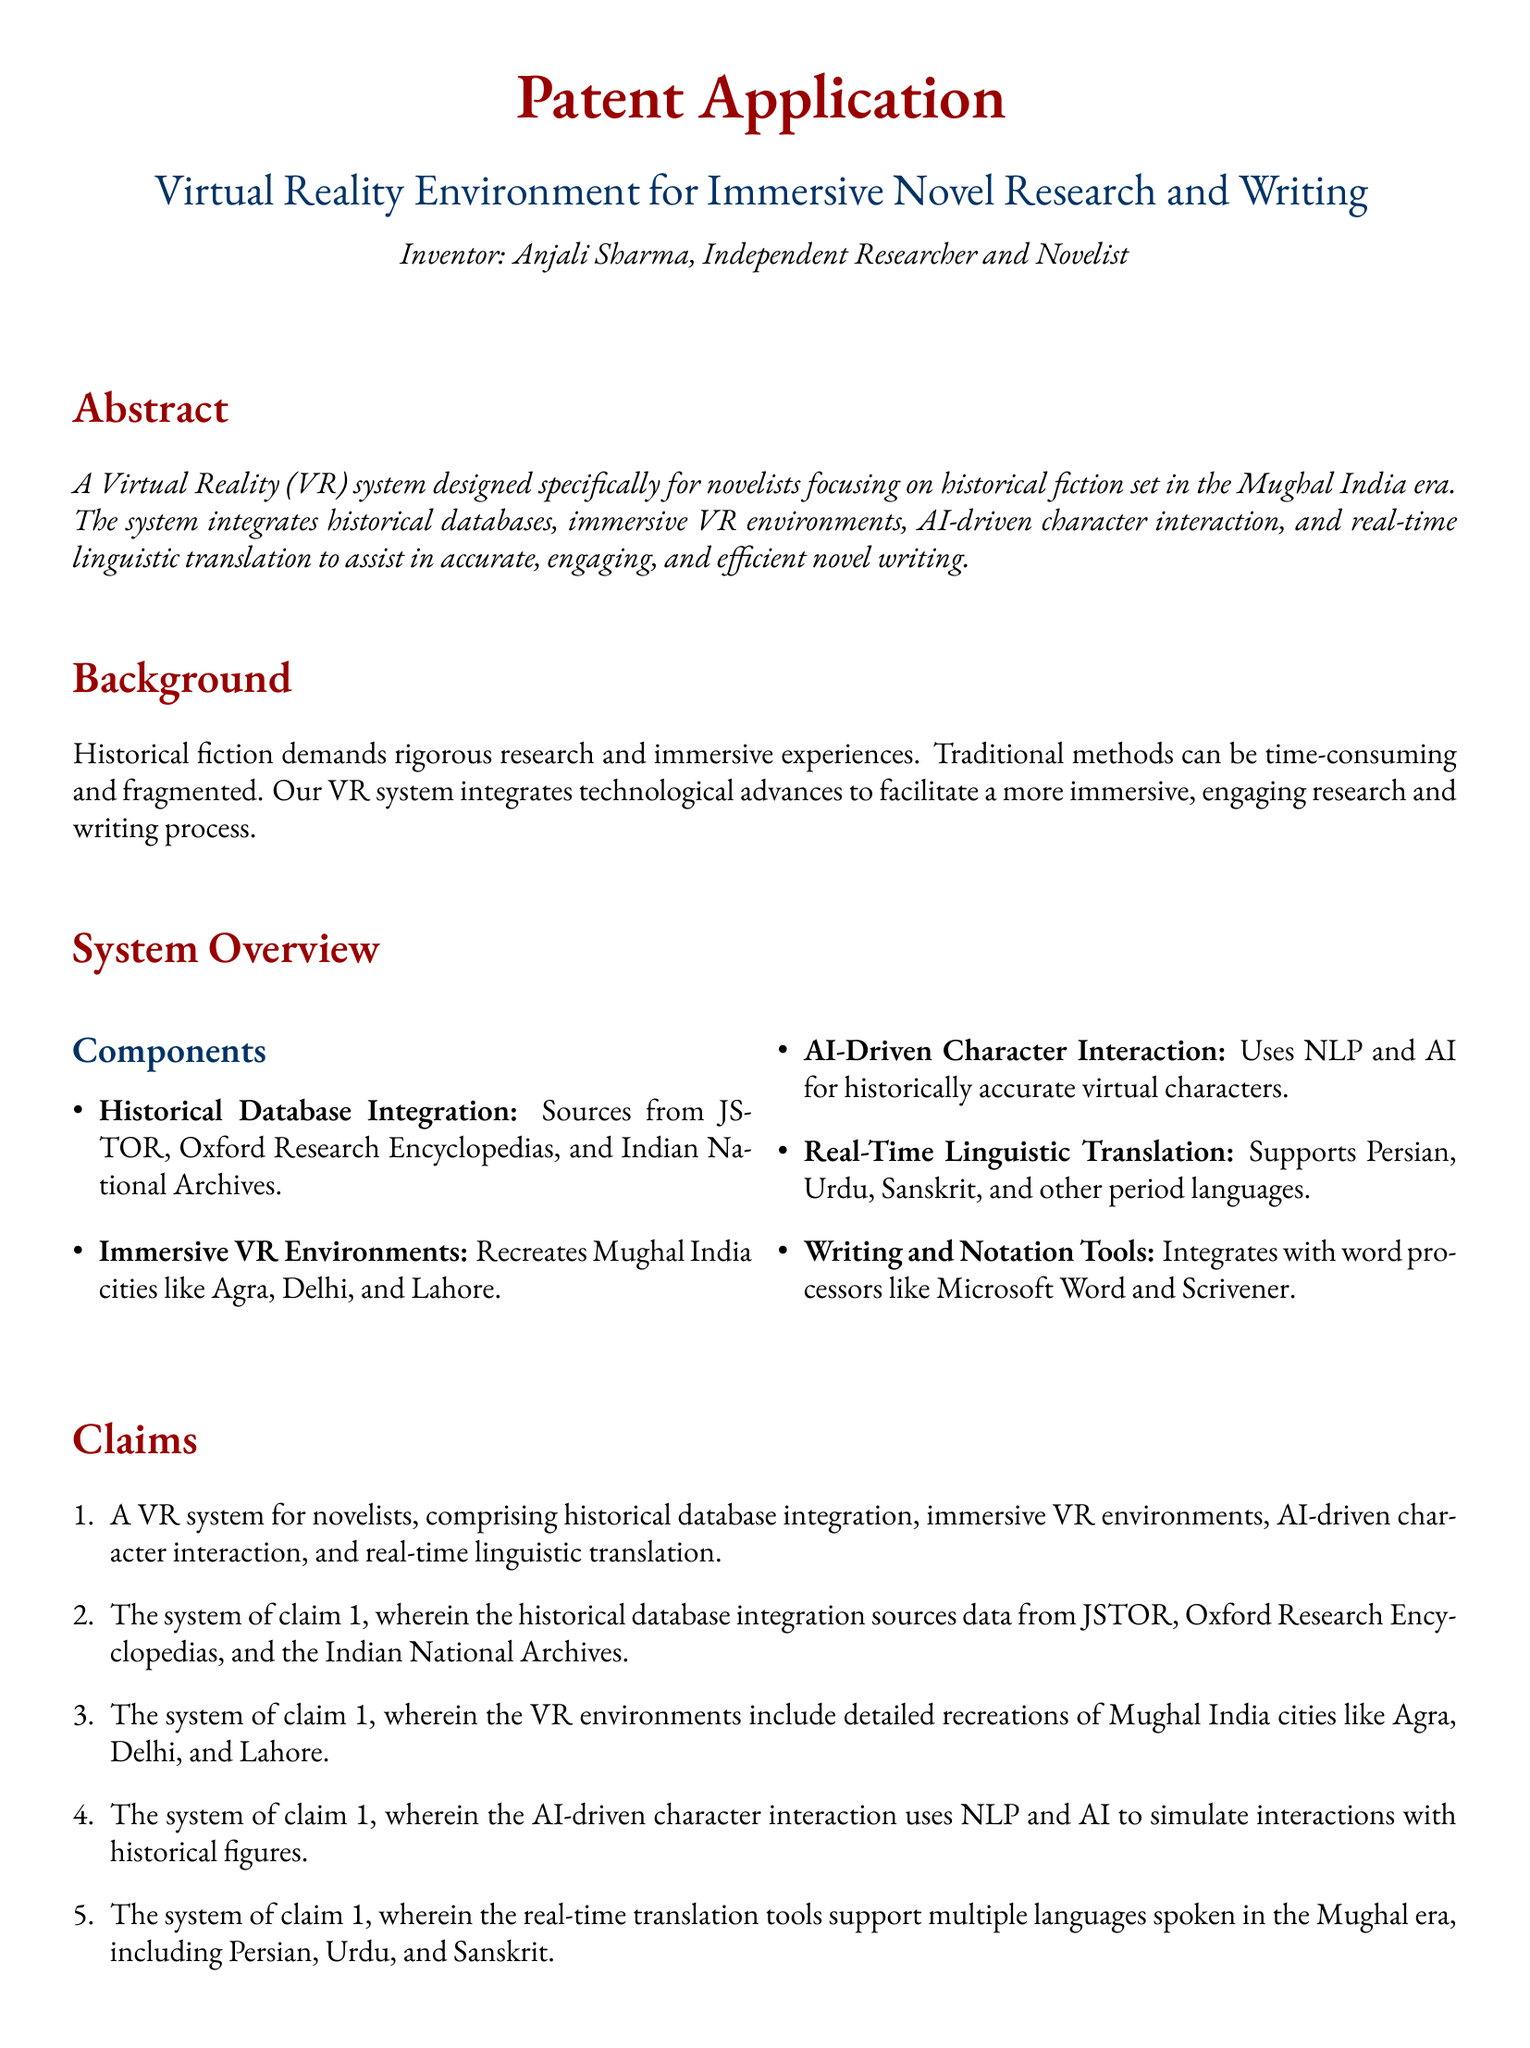What is the name of the inventor? The document states that the inventor is Anjali Sharma.
Answer: Anjali Sharma What is the main purpose of the VR system? The abstract describes the VR system's purpose as assisting novelists in writing historical fiction, focusing on the Mughal India era.
Answer: Immersive novel research and writing Which historical databases are integrated into the system? The claims specify that the system sources data from JSTOR, Oxford Research Encyclopedias, and the Indian National Archives.
Answer: JSTOR, Oxford Research Encyclopedias, Indian National Archives Which cities are recreated in the immersive VR environments? The document mentions that the VR environments include recreations of Agra, Delhi, and Lahore.
Answer: Agra, Delhi, Lahore What type of interaction does the AI-driven component simulate? The system is designed to simulate interactions with historical figures using NLP and AI.
Answer: Interactions with historical figures How many claims are listed in the document? The list of claims includes five distinct entries regarding the system's features.
Answer: Five What languages are supported by the real-time translation tools? The document states that the translation tools support Persian, Urdu, and Sanskrit.
Answer: Persian, Urdu, Sanskrit What kind of writing tools does the system integrate with? The system integrates with popular word processors like Microsoft Word and Scrivener, as mentioned in the components section.
Answer: Microsoft Word, Scrivener 